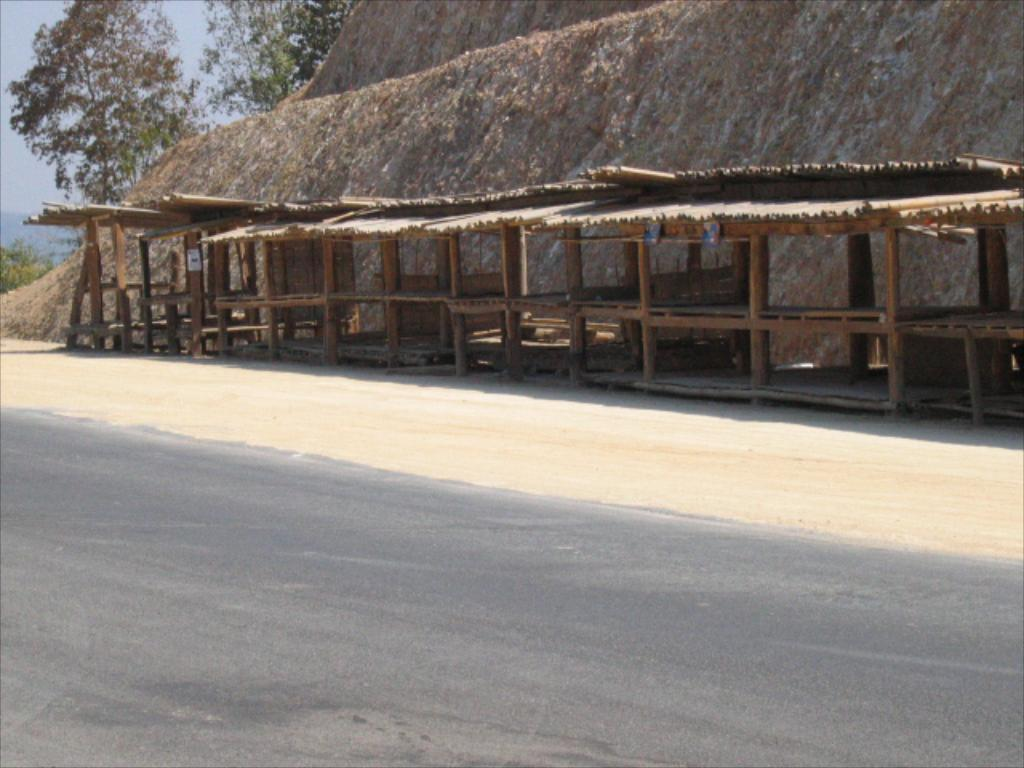What type of structure is present in the image? There is a shed in the image. What can be seen leading to the shed? There is a path in the image. What is visible in the background of the image? There are trees, plants, and the sky visible in the background of the image. What month is it in the image? The month cannot be determined from the image, as there are no specific clues or indicators of the time of year. What is the sister doing in the image? There is no mention of a sister or any person in the image; it only features a shed, a path, and background elements. 